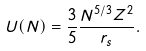Convert formula to latex. <formula><loc_0><loc_0><loc_500><loc_500>U ( N ) = \frac { 3 } { 5 } \frac { N ^ { 5 / 3 } Z ^ { 2 } } { r _ { s } } .</formula> 